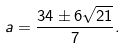<formula> <loc_0><loc_0><loc_500><loc_500>a = { \frac { 3 4 \pm 6 { \sqrt { 2 1 } } } { 7 } } .</formula> 